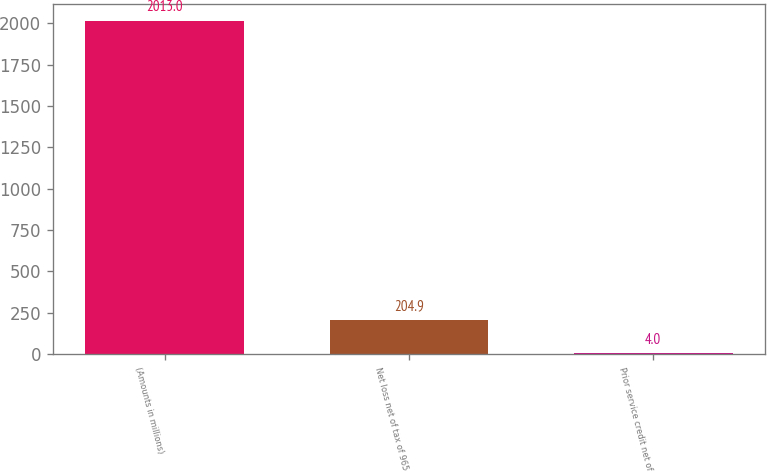Convert chart to OTSL. <chart><loc_0><loc_0><loc_500><loc_500><bar_chart><fcel>(Amounts in millions)<fcel>Net loss net of tax of 965<fcel>Prior service credit net of<nl><fcel>2013<fcel>204.9<fcel>4<nl></chart> 